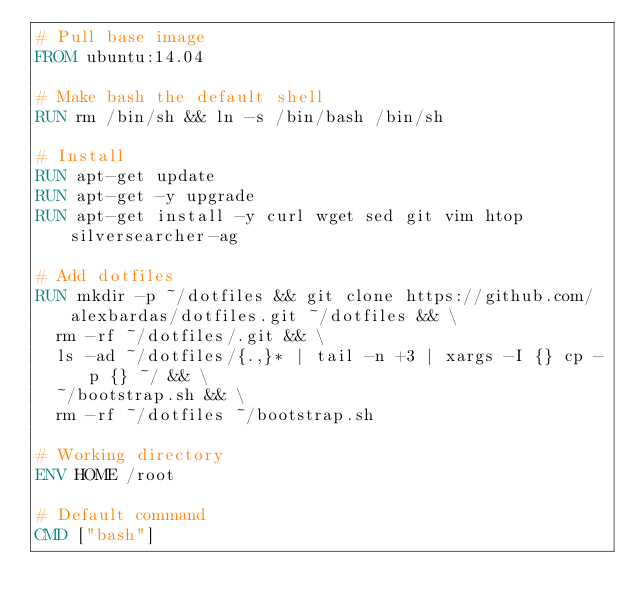<code> <loc_0><loc_0><loc_500><loc_500><_Dockerfile_># Pull base image
FROM ubuntu:14.04

# Make bash the default shell
RUN rm /bin/sh && ln -s /bin/bash /bin/sh

# Install
RUN apt-get update
RUN apt-get -y upgrade 
RUN apt-get install -y curl wget sed git vim htop silversearcher-ag

# Add dotfiles
RUN mkdir -p ~/dotfiles && git clone https://github.com/alexbardas/dotfiles.git ~/dotfiles && \
  rm -rf ~/dotfiles/.git && \ 
  ls -ad ~/dotfiles/{.,}* | tail -n +3 | xargs -I {} cp -p {} ~/ && \
  ~/bootstrap.sh && \
  rm -rf ~/dotfiles ~/bootstrap.sh

# Working directory
ENV HOME /root

# Default command
CMD ["bash"]

</code> 